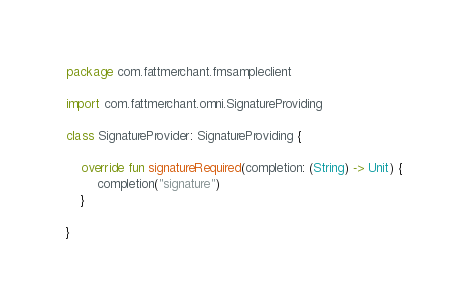<code> <loc_0><loc_0><loc_500><loc_500><_Kotlin_>package com.fattmerchant.fmsampleclient

import com.fattmerchant.omni.SignatureProviding

class SignatureProvider: SignatureProviding {

    override fun signatureRequired(completion: (String) -> Unit) {
        completion("signature")
    }

}</code> 